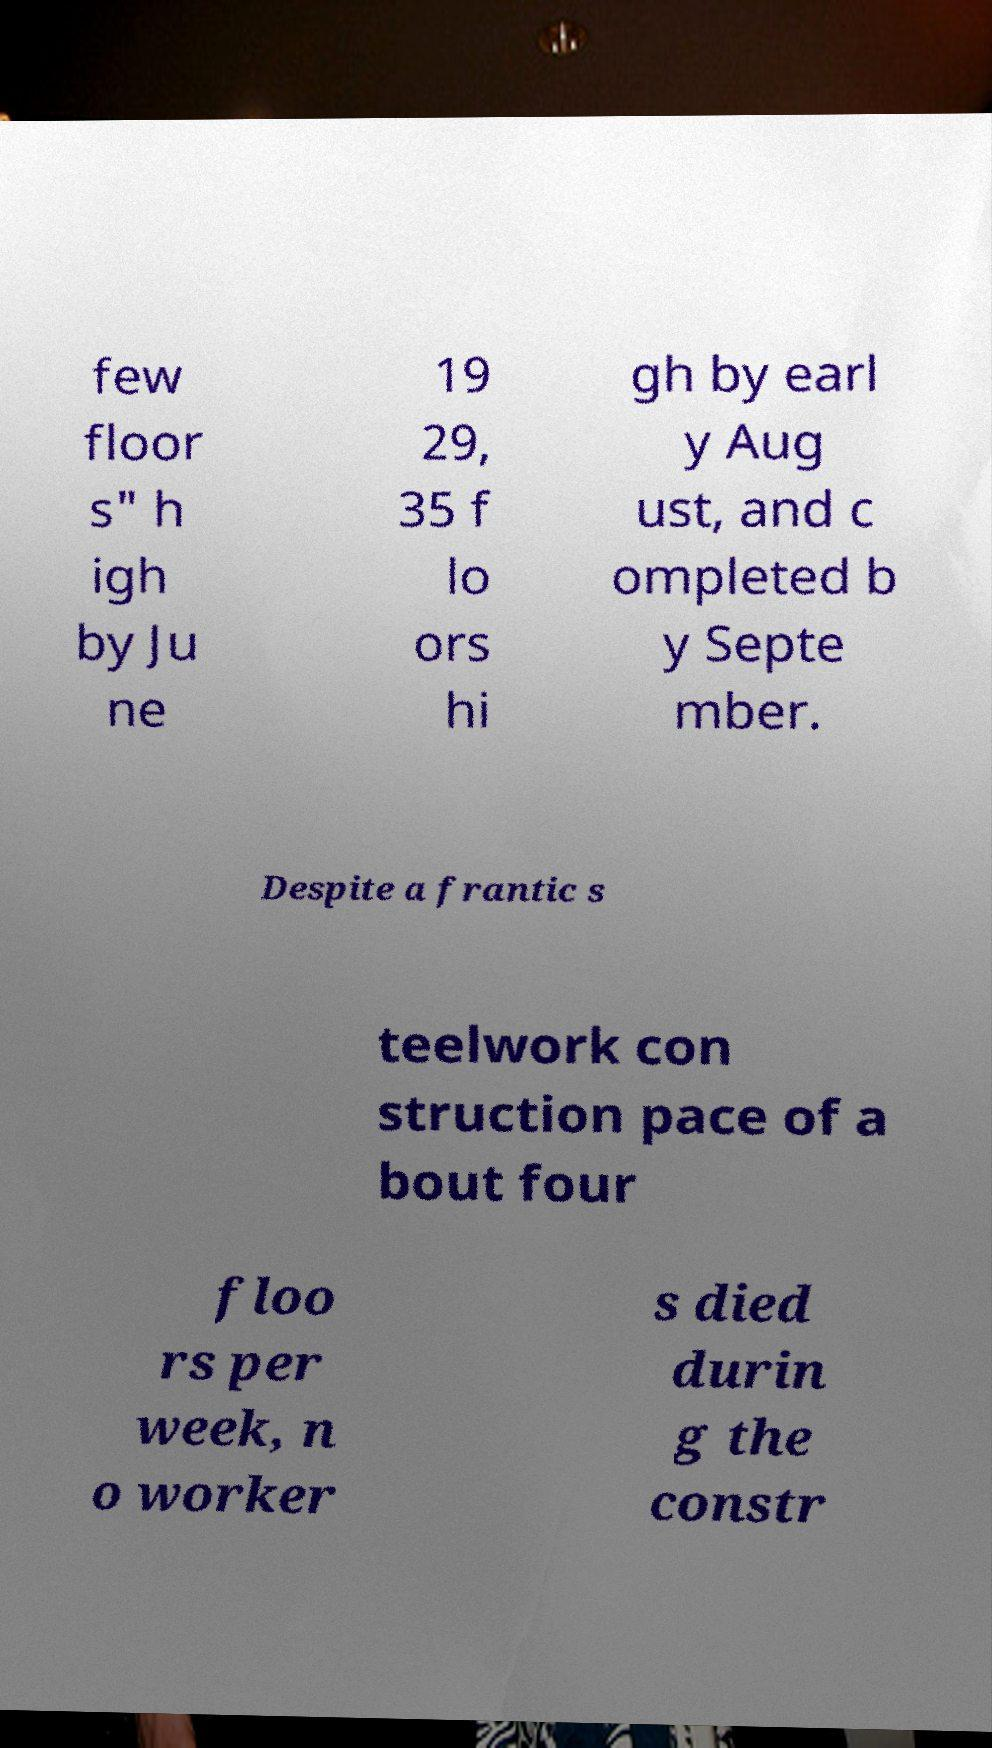Could you assist in decoding the text presented in this image and type it out clearly? few floor s" h igh by Ju ne 19 29, 35 f lo ors hi gh by earl y Aug ust, and c ompleted b y Septe mber. Despite a frantic s teelwork con struction pace of a bout four floo rs per week, n o worker s died durin g the constr 